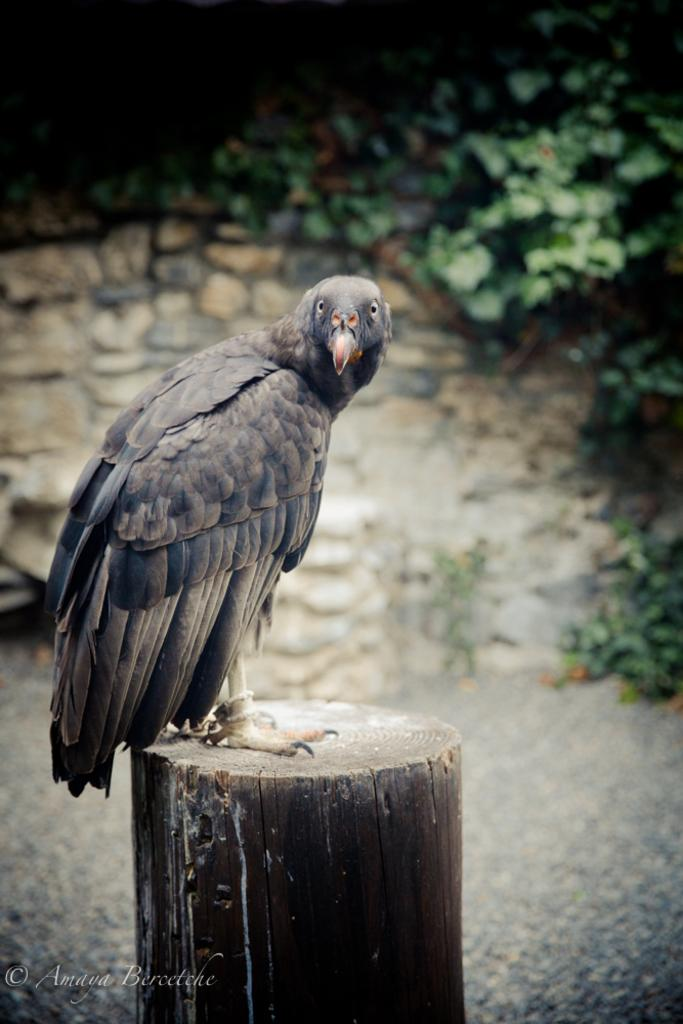What type of animal can be seen in the image? There is a bird in the image. Where is the bird located in the image? The bird is sitting on a tree branch. What can be seen in the background of the image? There are plants visible in the background of the image. What type of decision is the bird making in the image? There is no indication in the image that the bird is making a decision. Can you see a bottle in the image? No, there is no bottle present in the image. 